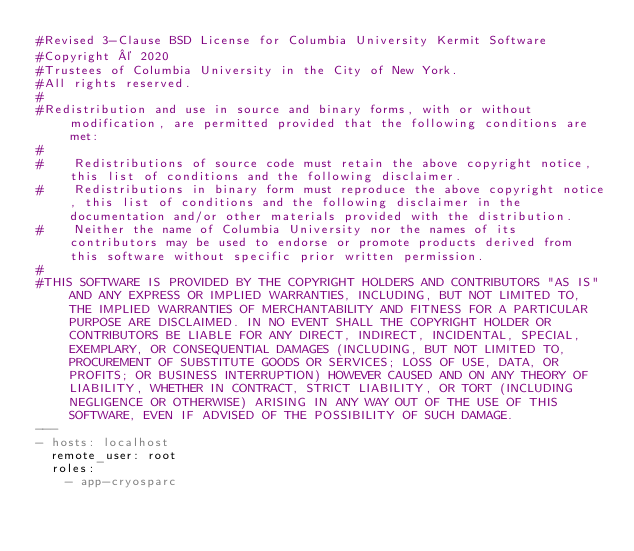<code> <loc_0><loc_0><loc_500><loc_500><_YAML_>#Revised 3-Clause BSD License for Columbia University Kermit Software
#Copyright © 2020
#Trustees of Columbia University in the City of New York.
#All rights reserved.
#
#Redistribution and use in source and binary forms, with or without modification, are permitted provided that the following conditions are met:
#
#    Redistributions of source code must retain the above copyright notice, this list of conditions and the following disclaimer.
#    Redistributions in binary form must reproduce the above copyright notice, this list of conditions and the following disclaimer in the documentation and/or other materials provided with the distribution.
#    Neither the name of Columbia University nor the names of its contributors may be used to endorse or promote products derived from this software without specific prior written permission. 
#
#THIS SOFTWARE IS PROVIDED BY THE COPYRIGHT HOLDERS AND CONTRIBUTORS "AS IS" AND ANY EXPRESS OR IMPLIED WARRANTIES, INCLUDING, BUT NOT LIMITED TO, THE IMPLIED WARRANTIES OF MERCHANTABILITY AND FITNESS FOR A PARTICULAR PURPOSE ARE DISCLAIMED. IN NO EVENT SHALL THE COPYRIGHT HOLDER OR CONTRIBUTORS BE LIABLE FOR ANY DIRECT, INDIRECT, INCIDENTAL, SPECIAL, EXEMPLARY, OR CONSEQUENTIAL DAMAGES (INCLUDING, BUT NOT LIMITED TO, PROCUREMENT OF SUBSTITUTE GOODS OR SERVICES; LOSS OF USE, DATA, OR PROFITS; OR BUSINESS INTERRUPTION) HOWEVER CAUSED AND ON ANY THEORY OF LIABILITY, WHETHER IN CONTRACT, STRICT LIABILITY, OR TORT (INCLUDING NEGLIGENCE OR OTHERWISE) ARISING IN ANY WAY OUT OF THE USE OF THIS SOFTWARE, EVEN IF ADVISED OF THE POSSIBILITY OF SUCH DAMAGE.
---
- hosts: localhost
  remote_user: root
  roles:
    - app-cryosparc</code> 